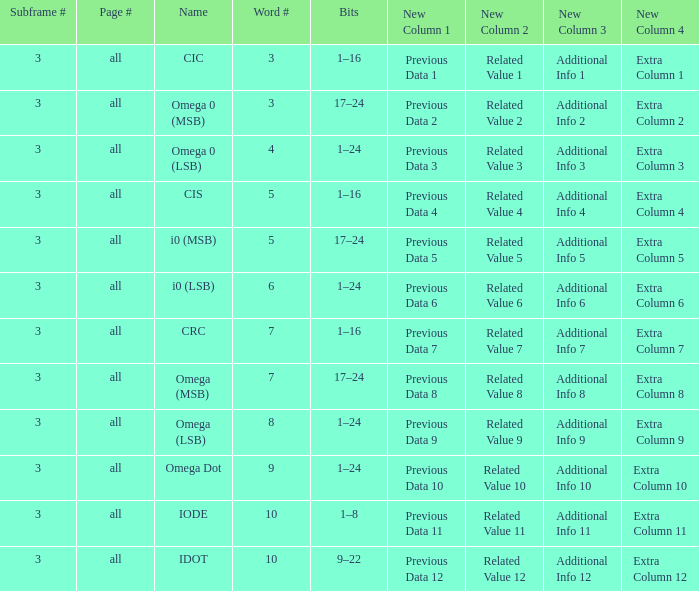Would you mind parsing the complete table? {'header': ['Subframe #', 'Page #', 'Name', 'Word #', 'Bits', 'New Column 1', 'New Column 2', 'New Column 3', 'New Column 4'], 'rows': [['3', 'all', 'CIC', '3', '1–16', 'Previous Data 1', 'Related Value 1', 'Additional Info 1', 'Extra Column 1'], ['3', 'all', 'Omega 0 (MSB)', '3', '17–24', 'Previous Data 2', 'Related Value 2', 'Additional Info 2', 'Extra Column 2'], ['3', 'all', 'Omega 0 (LSB)', '4', '1–24', 'Previous Data 3', 'Related Value 3', 'Additional Info 3', 'Extra Column 3'], ['3', 'all', 'CIS', '5', '1–16', 'Previous Data 4', 'Related Value 4', 'Additional Info 4', 'Extra Column 4'], ['3', 'all', 'i0 (MSB)', '5', '17–24', 'Previous Data 5', 'Related Value 5', 'Additional Info 5', 'Extra Column 5'], ['3', 'all', 'i0 (LSB)', '6', '1–24', 'Previous Data 6', 'Related Value 6', 'Additional Info 6', 'Extra Column 6'], ['3', 'all', 'CRC', '7', '1–16', 'Previous Data 7', 'Related Value 7', 'Additional Info 7', 'Extra Column 7'], ['3', 'all', 'Omega (MSB)', '7', '17–24', 'Previous Data 8', 'Related Value 8', 'Additional Info 8', 'Extra Column 8'], ['3', 'all', 'Omega (LSB)', '8', '1–24', 'Previous Data 9', 'Related Value 9', 'Additional Info 9', 'Extra Column 9'], ['3', 'all', 'Omega Dot', '9', '1–24', 'Previous Data 10', 'Related Value 10', 'Additional Info 10', 'Extra Column 10'], ['3', 'all', 'IODE', '10', '1–8', 'Previous Data 11', 'Related Value 11', 'Additional Info 11', 'Extra Column 11'], ['3', 'all', 'IDOT', '10', '9–22', 'Previous Data 12', 'Related Value 12', 'Additional Info 12', 'Extra Column 12']]} What is the entire word count with a subframe count above 3? None. 